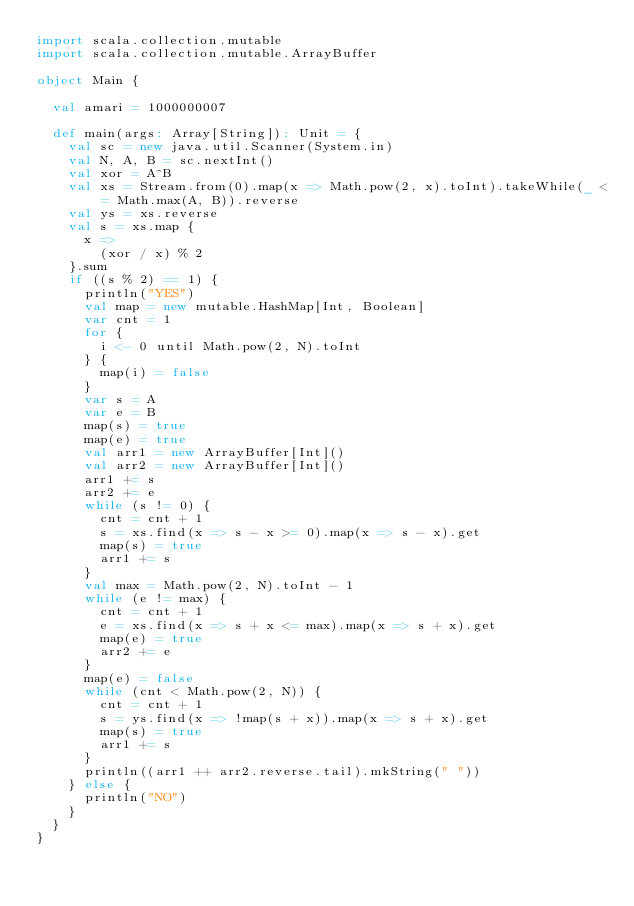<code> <loc_0><loc_0><loc_500><loc_500><_Scala_>import scala.collection.mutable
import scala.collection.mutable.ArrayBuffer

object Main {

  val amari = 1000000007

  def main(args: Array[String]): Unit = {
    val sc = new java.util.Scanner(System.in)
    val N, A, B = sc.nextInt()
    val xor = A^B
    val xs = Stream.from(0).map(x => Math.pow(2, x).toInt).takeWhile(_ <= Math.max(A, B)).reverse
    val ys = xs.reverse
    val s = xs.map {
      x =>
        (xor / x) % 2
    }.sum
    if ((s % 2) == 1) {
      println("YES")
      val map = new mutable.HashMap[Int, Boolean]
      var cnt = 1
      for {
        i <- 0 until Math.pow(2, N).toInt
      } {
        map(i) = false
      }
      var s = A
      var e = B
      map(s) = true
      map(e) = true
      val arr1 = new ArrayBuffer[Int]()
      val arr2 = new ArrayBuffer[Int]()
      arr1 += s
      arr2 += e
      while (s != 0) {
        cnt = cnt + 1
        s = xs.find(x => s - x >= 0).map(x => s - x).get
        map(s) = true
        arr1 += s
      }
      val max = Math.pow(2, N).toInt - 1
      while (e != max) {
        cnt = cnt + 1
        e = xs.find(x => s + x <= max).map(x => s + x).get
        map(e) = true
        arr2 += e
      }
      map(e) = false
      while (cnt < Math.pow(2, N)) {
        cnt = cnt + 1
        s = ys.find(x => !map(s + x)).map(x => s + x).get
        map(s) = true
        arr1 += s
      }
      println((arr1 ++ arr2.reverse.tail).mkString(" "))
    } else {
      println("NO")
    }
  }
}
</code> 